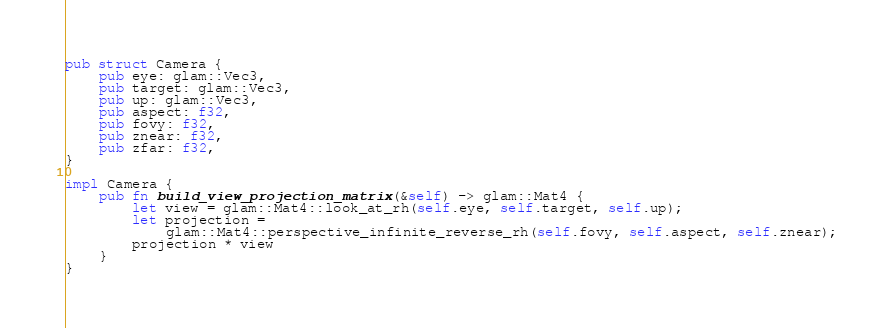Convert code to text. <code><loc_0><loc_0><loc_500><loc_500><_Rust_>pub struct Camera {
    pub eye: glam::Vec3,
    pub target: glam::Vec3,
    pub up: glam::Vec3,
    pub aspect: f32,
    pub fovy: f32,
    pub znear: f32,
    pub zfar: f32,
}

impl Camera {
    pub fn build_view_projection_matrix(&self) -> glam::Mat4 {
        let view = glam::Mat4::look_at_rh(self.eye, self.target, self.up);
        let projection =
            glam::Mat4::perspective_infinite_reverse_rh(self.fovy, self.aspect, self.znear);
        projection * view
    }
}
</code> 